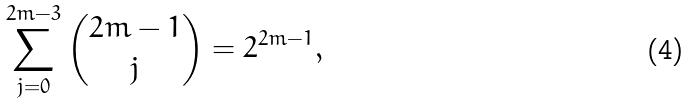<formula> <loc_0><loc_0><loc_500><loc_500>\sum _ { j = 0 } ^ { 2 m - 3 } \binom { 2 m - 1 } { j } = 2 ^ { 2 m - 1 } ,</formula> 